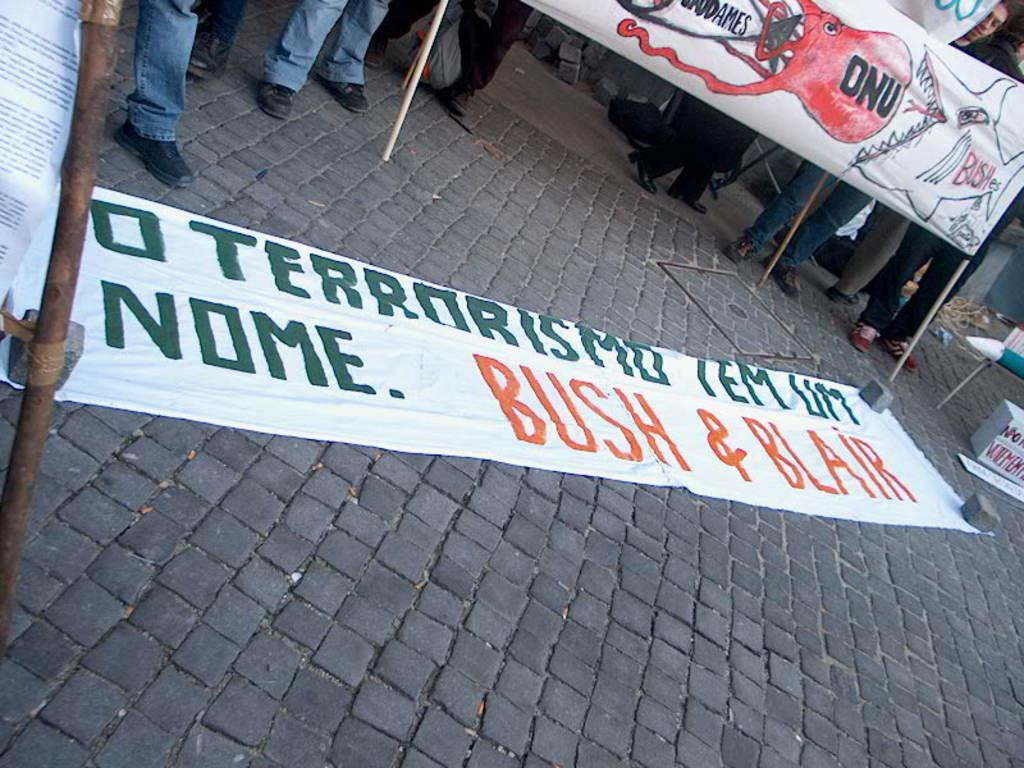What can be seen hanging in the image? There are banners in the image. What are the people in the image doing? The people are standing on a surface in the image. What type of calendar is hanging on the wall in the image? There is no calendar present in the image; only banners are visible. Is there a ship visible in the image? No, there is no ship present in the image. 